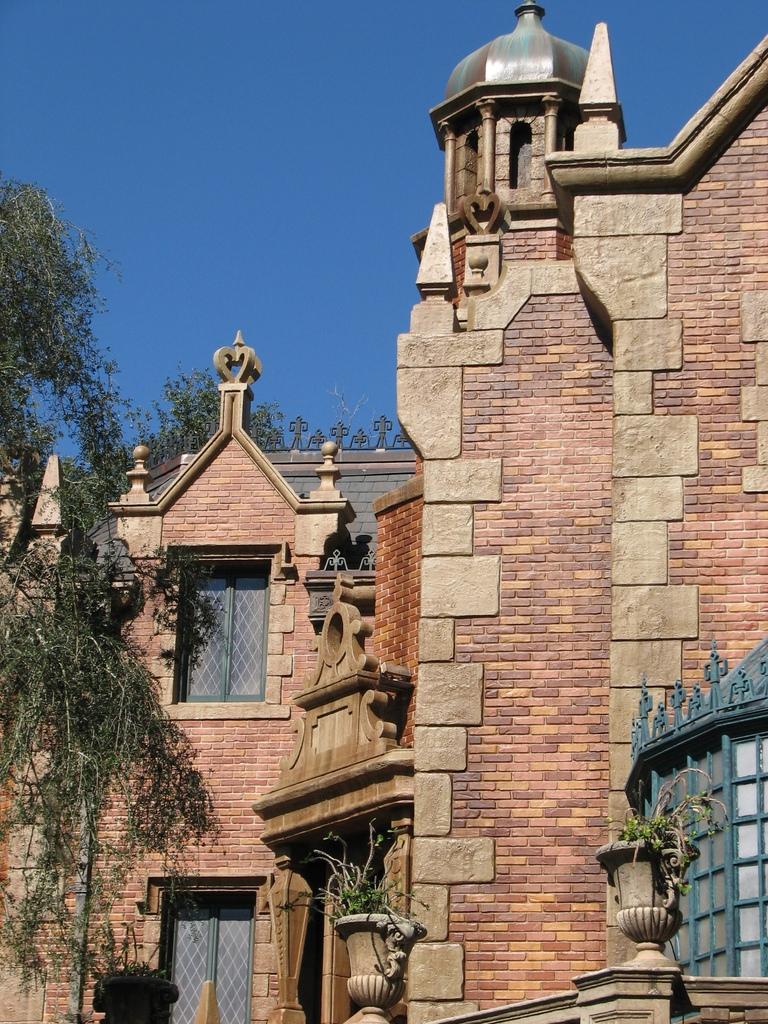Can you describe this image briefly? In this image in front there are trees and we can see buildings with the windows. In the background there is sky. 